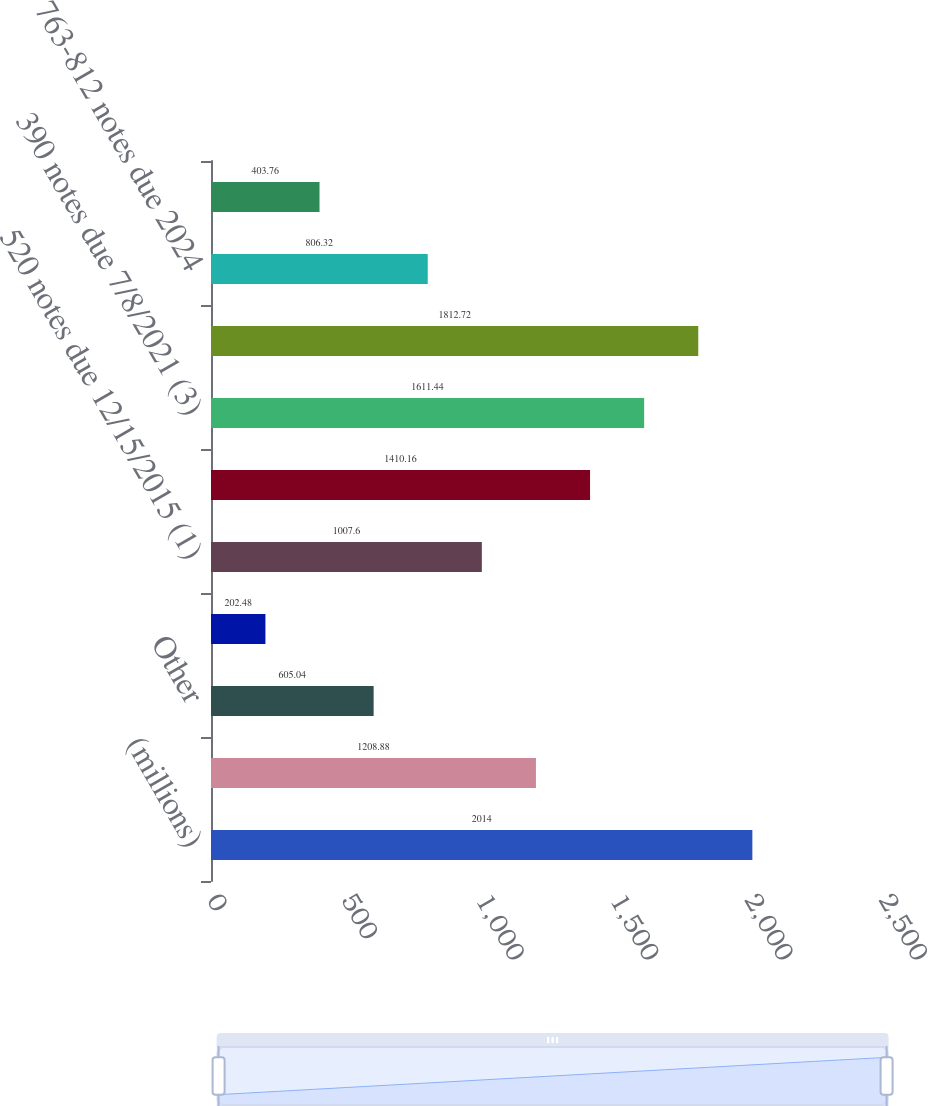<chart> <loc_0><loc_0><loc_500><loc_500><bar_chart><fcel>(millions)<fcel>Commercial paper<fcel>Other<fcel>Weighted-average interest rate<fcel>520 notes due 12/15/2015 (1)<fcel>575 notes due 12/15/2017 (2)<fcel>390 notes due 7/8/2021 (3)<fcel>350 notes due 8/19/2023 (4)<fcel>763-812 notes due 2024<fcel>Unamortized discounts and fair<nl><fcel>2014<fcel>1208.88<fcel>605.04<fcel>202.48<fcel>1007.6<fcel>1410.16<fcel>1611.44<fcel>1812.72<fcel>806.32<fcel>403.76<nl></chart> 